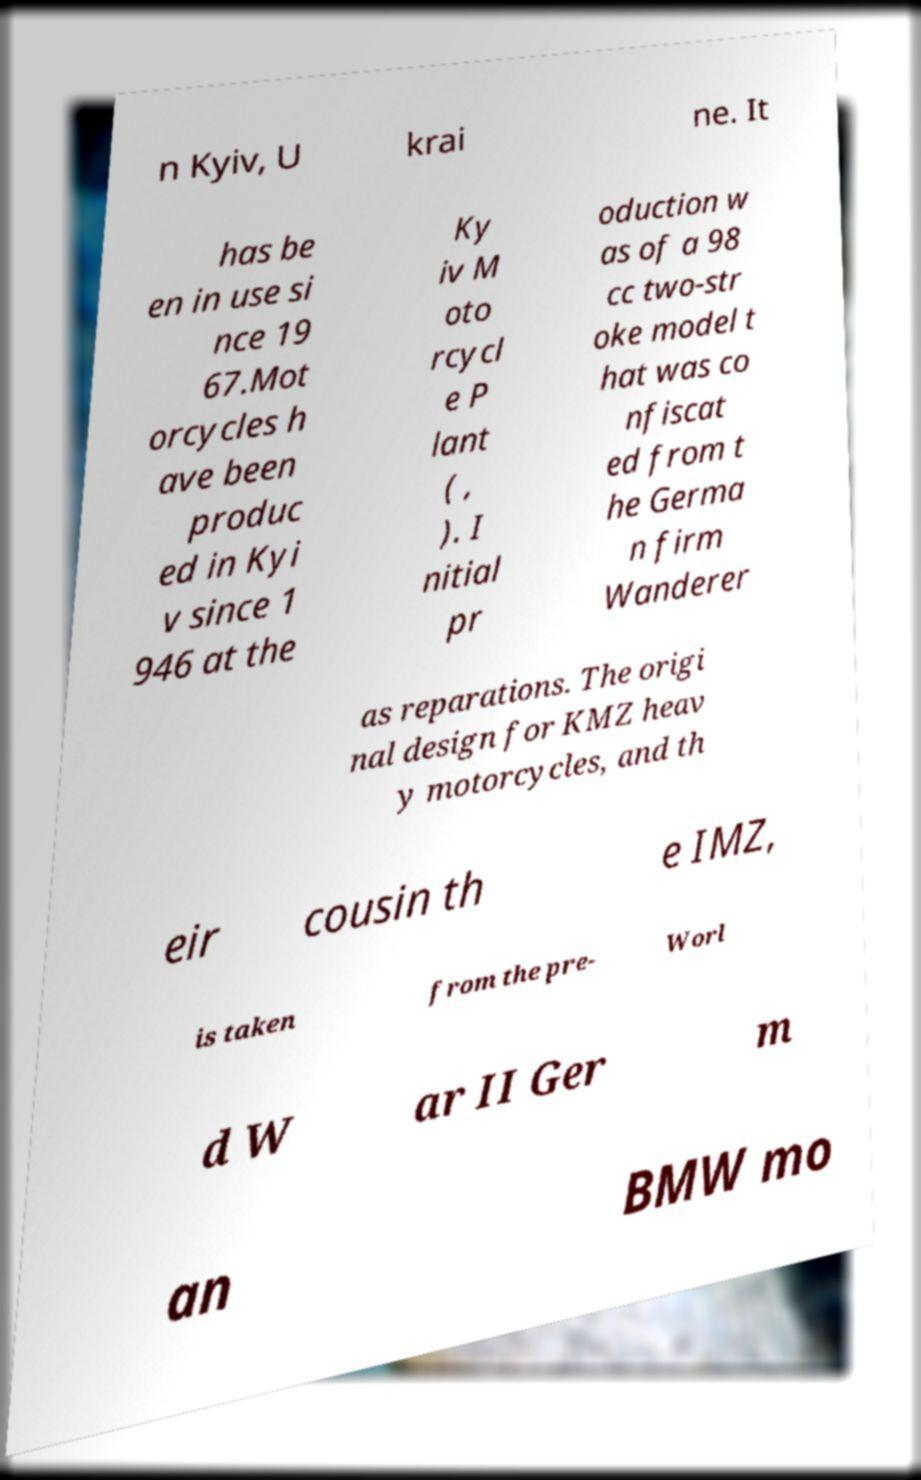For documentation purposes, I need the text within this image transcribed. Could you provide that? n Kyiv, U krai ne. It has be en in use si nce 19 67.Mot orcycles h ave been produc ed in Kyi v since 1 946 at the Ky iv M oto rcycl e P lant ( , ). I nitial pr oduction w as of a 98 cc two-str oke model t hat was co nfiscat ed from t he Germa n firm Wanderer as reparations. The origi nal design for KMZ heav y motorcycles, and th eir cousin th e IMZ, is taken from the pre- Worl d W ar II Ger m an BMW mo 